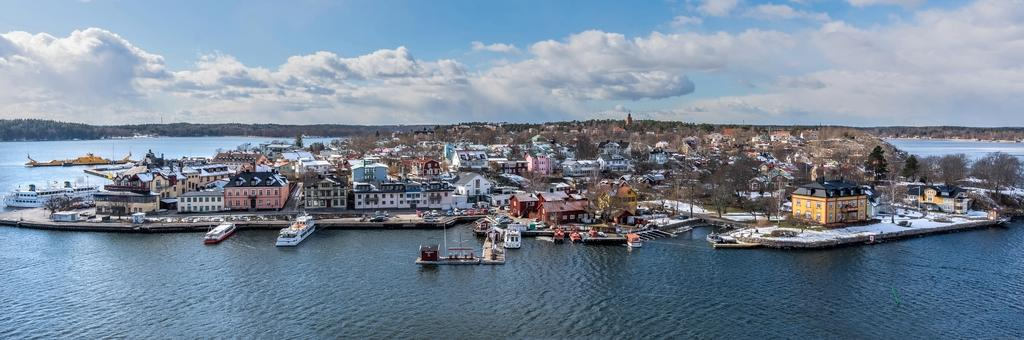What type of structures can be seen in the image? There are buildings in the image. What other natural elements are present in the image? There are trees in the image. What type of vehicles can be seen in the image? There are boats and a ship in the image. What is the primary body of water in the image? There is water visible in the image. How would you describe the sky in the image? The sky is blue and cloudy in the image. Where are the rabbits playing in the image? There are no rabbits present in the image. What type of lunch is being served on the ship in the image? There is no lunch or any indication of food being served on the ship in the image. 